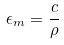<formula> <loc_0><loc_0><loc_500><loc_500>\epsilon _ { m } = \frac { c } { \rho }</formula> 